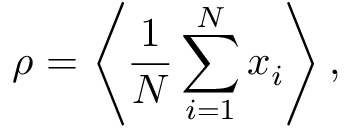Convert formula to latex. <formula><loc_0><loc_0><loc_500><loc_500>\rho = \left \langle \frac { 1 } { N } \sum _ { i = 1 } ^ { N } x _ { i } \right \rangle ,</formula> 